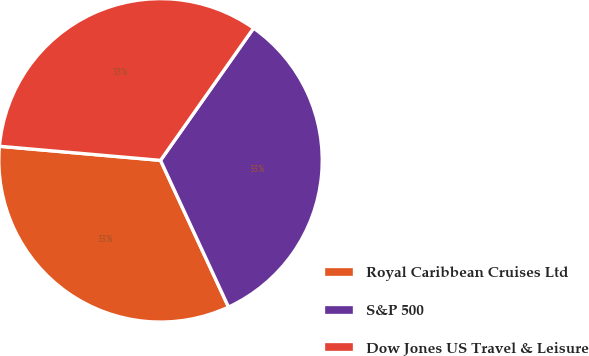Convert chart. <chart><loc_0><loc_0><loc_500><loc_500><pie_chart><fcel>Royal Caribbean Cruises Ltd<fcel>S&P 500<fcel>Dow Jones US Travel & Leisure<nl><fcel>33.3%<fcel>33.33%<fcel>33.37%<nl></chart> 